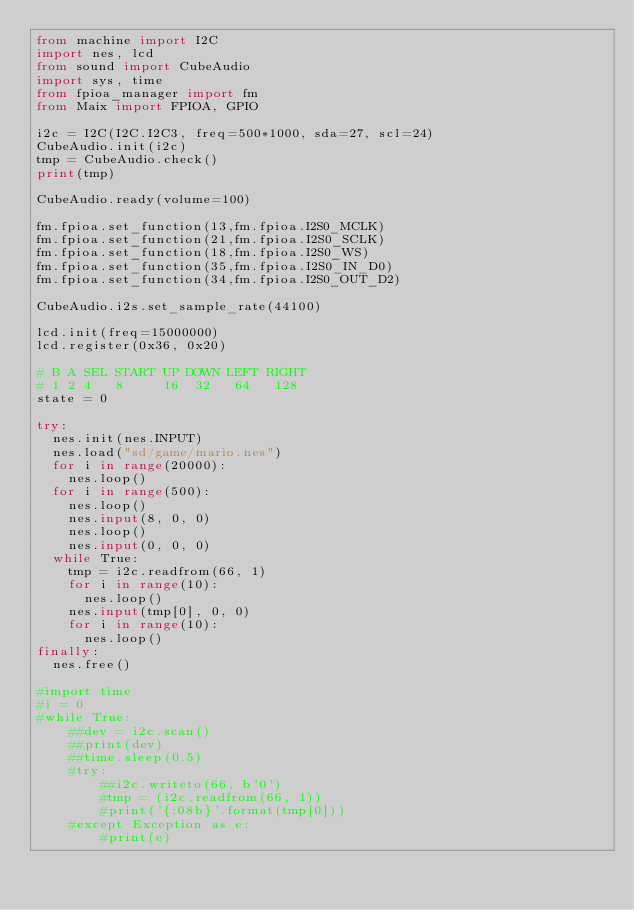Convert code to text. <code><loc_0><loc_0><loc_500><loc_500><_Python_>from machine import I2C
import nes, lcd
from sound import CubeAudio
import sys, time
from fpioa_manager import fm
from Maix import FPIOA, GPIO

i2c = I2C(I2C.I2C3, freq=500*1000, sda=27, scl=24)
CubeAudio.init(i2c)
tmp = CubeAudio.check()
print(tmp)

CubeAudio.ready(volume=100)

fm.fpioa.set_function(13,fm.fpioa.I2S0_MCLK)
fm.fpioa.set_function(21,fm.fpioa.I2S0_SCLK)
fm.fpioa.set_function(18,fm.fpioa.I2S0_WS)
fm.fpioa.set_function(35,fm.fpioa.I2S0_IN_D0)
fm.fpioa.set_function(34,fm.fpioa.I2S0_OUT_D2)

CubeAudio.i2s.set_sample_rate(44100)

lcd.init(freq=15000000)
lcd.register(0x36, 0x20)

# B A SEL START UP DOWN LEFT RIGHT
# 1 2 4   8     16  32   64   128
state = 0

try:
  nes.init(nes.INPUT)
  nes.load("sd/game/mario.nes")
  for i in range(20000):
    nes.loop()
  for i in range(500):
    nes.loop()
    nes.input(8, 0, 0)
    nes.loop()
    nes.input(0, 0, 0)
  while True:
    tmp = i2c.readfrom(66, 1)
    for i in range(10):
      nes.loop()
    nes.input(tmp[0], 0, 0)
    for i in range(10):
      nes.loop()
finally:
  nes.free()

#import time
#i = 0
#while True:
    ##dev = i2c.scan()
    ##print(dev)
    ##time.sleep(0.5)
    #try:
        ##i2c.writeto(66, b'0')
        #tmp = (i2c.readfrom(66, 1))
        #print('{:08b}'.format(tmp[0]))
    #except Exception as e:
        #print(e)
</code> 